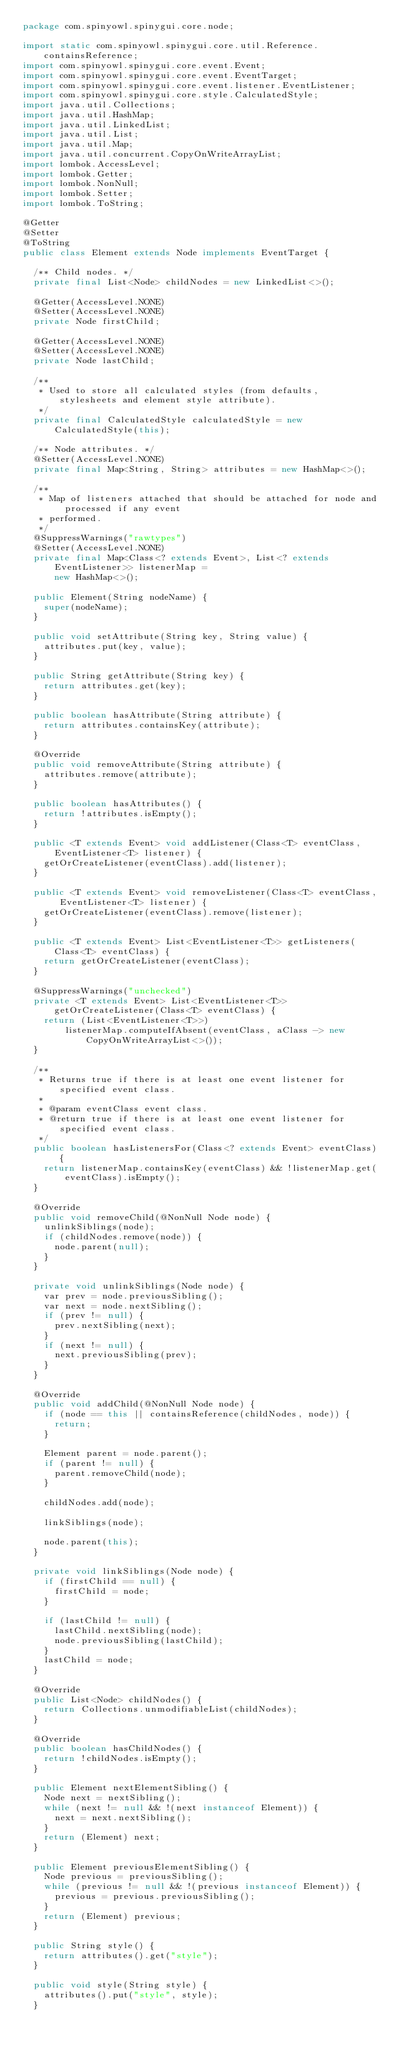<code> <loc_0><loc_0><loc_500><loc_500><_Java_>package com.spinyowl.spinygui.core.node;

import static com.spinyowl.spinygui.core.util.Reference.containsReference;
import com.spinyowl.spinygui.core.event.Event;
import com.spinyowl.spinygui.core.event.EventTarget;
import com.spinyowl.spinygui.core.event.listener.EventListener;
import com.spinyowl.spinygui.core.style.CalculatedStyle;
import java.util.Collections;
import java.util.HashMap;
import java.util.LinkedList;
import java.util.List;
import java.util.Map;
import java.util.concurrent.CopyOnWriteArrayList;
import lombok.AccessLevel;
import lombok.Getter;
import lombok.NonNull;
import lombok.Setter;
import lombok.ToString;

@Getter
@Setter
@ToString
public class Element extends Node implements EventTarget {

  /** Child nodes. */
  private final List<Node> childNodes = new LinkedList<>();

  @Getter(AccessLevel.NONE)
  @Setter(AccessLevel.NONE)
  private Node firstChild;

  @Getter(AccessLevel.NONE)
  @Setter(AccessLevel.NONE)
  private Node lastChild;

  /**
   * Used to store all calculated styles (from defaults, stylesheets and element style attribute).
   */
  private final CalculatedStyle calculatedStyle = new CalculatedStyle(this);

  /** Node attributes. */
  @Setter(AccessLevel.NONE)
  private final Map<String, String> attributes = new HashMap<>();

  /**
   * Map of listeners attached that should be attached for node and processed if any event
   * performed.
   */
  @SuppressWarnings("rawtypes")
  @Setter(AccessLevel.NONE)
  private final Map<Class<? extends Event>, List<? extends EventListener>> listenerMap =
      new HashMap<>();

  public Element(String nodeName) {
    super(nodeName);
  }

  public void setAttribute(String key, String value) {
    attributes.put(key, value);
  }

  public String getAttribute(String key) {
    return attributes.get(key);
  }

  public boolean hasAttribute(String attribute) {
    return attributes.containsKey(attribute);
  }

  @Override
  public void removeAttribute(String attribute) {
    attributes.remove(attribute);
  }

  public boolean hasAttributes() {
    return !attributes.isEmpty();
  }

  public <T extends Event> void addListener(Class<T> eventClass, EventListener<T> listener) {
    getOrCreateListener(eventClass).add(listener);
  }

  public <T extends Event> void removeListener(Class<T> eventClass, EventListener<T> listener) {
    getOrCreateListener(eventClass).remove(listener);
  }

  public <T extends Event> List<EventListener<T>> getListeners(Class<T> eventClass) {
    return getOrCreateListener(eventClass);
  }

  @SuppressWarnings("unchecked")
  private <T extends Event> List<EventListener<T>> getOrCreateListener(Class<T> eventClass) {
    return (List<EventListener<T>>)
        listenerMap.computeIfAbsent(eventClass, aClass -> new CopyOnWriteArrayList<>());
  }

  /**
   * Returns true if there is at least one event listener for specified event class.
   *
   * @param eventClass event class.
   * @return true if there is at least one event listener for specified event class.
   */
  public boolean hasListenersFor(Class<? extends Event> eventClass) {
    return listenerMap.containsKey(eventClass) && !listenerMap.get(eventClass).isEmpty();
  }

  @Override
  public void removeChild(@NonNull Node node) {
    unlinkSiblings(node);
    if (childNodes.remove(node)) {
      node.parent(null);
    }
  }

  private void unlinkSiblings(Node node) {
    var prev = node.previousSibling();
    var next = node.nextSibling();
    if (prev != null) {
      prev.nextSibling(next);
    }
    if (next != null) {
      next.previousSibling(prev);
    }
  }

  @Override
  public void addChild(@NonNull Node node) {
    if (node == this || containsReference(childNodes, node)) {
      return;
    }

    Element parent = node.parent();
    if (parent != null) {
      parent.removeChild(node);
    }

    childNodes.add(node);

    linkSiblings(node);

    node.parent(this);
  }

  private void linkSiblings(Node node) {
    if (firstChild == null) {
      firstChild = node;
    }

    if (lastChild != null) {
      lastChild.nextSibling(node);
      node.previousSibling(lastChild);
    }
    lastChild = node;
  }

  @Override
  public List<Node> childNodes() {
    return Collections.unmodifiableList(childNodes);
  }

  @Override
  public boolean hasChildNodes() {
    return !childNodes.isEmpty();
  }

  public Element nextElementSibling() {
    Node next = nextSibling();
    while (next != null && !(next instanceof Element)) {
      next = next.nextSibling();
    }
    return (Element) next;
  }

  public Element previousElementSibling() {
    Node previous = previousSibling();
    while (previous != null && !(previous instanceof Element)) {
      previous = previous.previousSibling();
    }
    return (Element) previous;
  }

  public String style() {
    return attributes().get("style");
  }

  public void style(String style) {
    attributes().put("style", style);
  }
</code> 